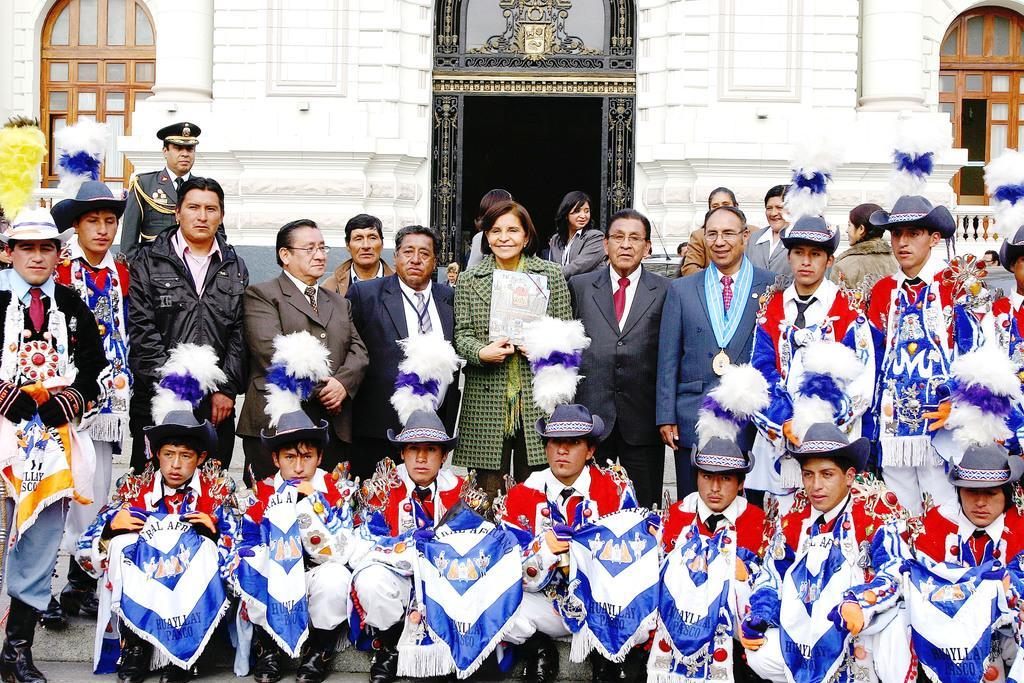Can you describe this image briefly? This is an outside view. Here I can see a crowd of people giving pose for the picture. On the right side few people are wearing costumes, caps on their heads and few people are wearing suits. In the background, I can see some more people and also there is a building. 